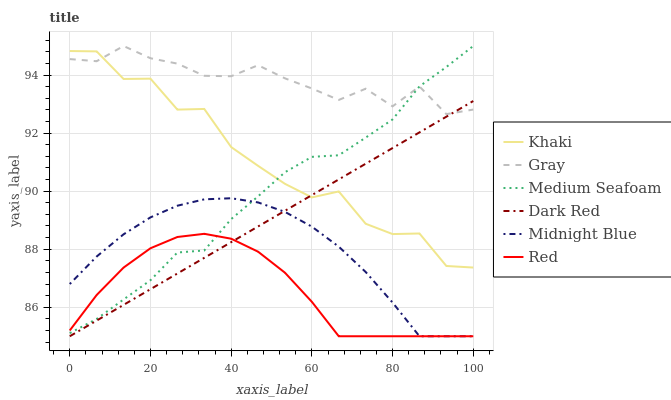Does Red have the minimum area under the curve?
Answer yes or no. Yes. Does Gray have the maximum area under the curve?
Answer yes or no. Yes. Does Khaki have the minimum area under the curve?
Answer yes or no. No. Does Khaki have the maximum area under the curve?
Answer yes or no. No. Is Dark Red the smoothest?
Answer yes or no. Yes. Is Khaki the roughest?
Answer yes or no. Yes. Is Midnight Blue the smoothest?
Answer yes or no. No. Is Midnight Blue the roughest?
Answer yes or no. No. Does Midnight Blue have the lowest value?
Answer yes or no. Yes. Does Khaki have the lowest value?
Answer yes or no. No. Does Medium Seafoam have the highest value?
Answer yes or no. Yes. Does Khaki have the highest value?
Answer yes or no. No. Is Red less than Gray?
Answer yes or no. Yes. Is Gray greater than Red?
Answer yes or no. Yes. Does Medium Seafoam intersect Khaki?
Answer yes or no. Yes. Is Medium Seafoam less than Khaki?
Answer yes or no. No. Is Medium Seafoam greater than Khaki?
Answer yes or no. No. Does Red intersect Gray?
Answer yes or no. No. 